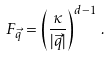Convert formula to latex. <formula><loc_0><loc_0><loc_500><loc_500>F _ { \vec { q } } = \left ( \frac { \kappa } { | { \vec { q } } | } \right ) ^ { d - 1 } \, .</formula> 